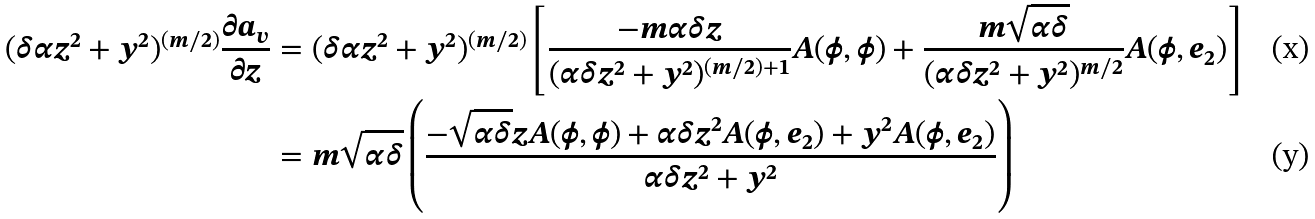Convert formula to latex. <formula><loc_0><loc_0><loc_500><loc_500>( \delta \alpha z ^ { 2 } + y ^ { 2 } ) ^ { ( m / 2 ) } \frac { \partial a _ { v } } { \partial z } & = ( \delta \alpha z ^ { 2 } + y ^ { 2 } ) ^ { ( m / 2 ) } \left [ \frac { - m \alpha \delta z } { ( \alpha \delta z ^ { 2 } + y ^ { 2 } ) ^ { ( m / 2 ) + 1 } } A ( \phi , \phi ) + \frac { m \sqrt { \alpha \delta } } { ( \alpha \delta z ^ { 2 } + y ^ { 2 } ) ^ { m / 2 } } A ( \phi , e _ { 2 } ) \right ] \\ & = m \sqrt { \alpha \delta } \left ( \frac { - \sqrt { \alpha \delta } z A ( \phi , \phi ) + \alpha \delta z ^ { 2 } A ( \phi , e _ { 2 } ) + y ^ { 2 } A ( \phi , e _ { 2 } ) } { \alpha \delta z ^ { 2 } + y ^ { 2 } } \right )</formula> 